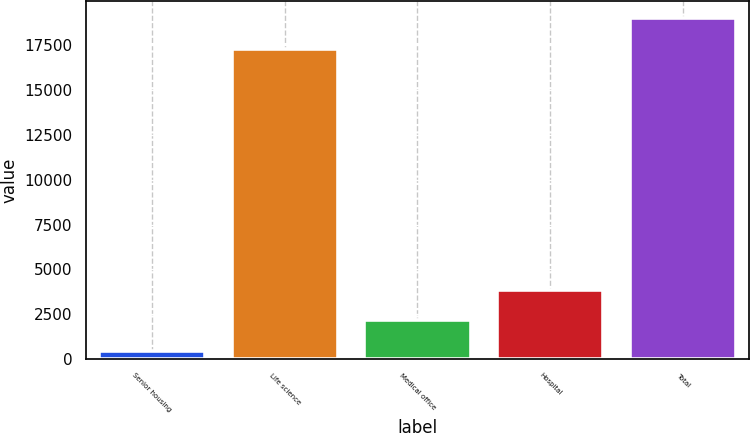<chart> <loc_0><loc_0><loc_500><loc_500><bar_chart><fcel>Senior housing<fcel>Life science<fcel>Medical office<fcel>Hospital<fcel>Total<nl><fcel>466<fcel>17321<fcel>2157<fcel>3848<fcel>19012<nl></chart> 